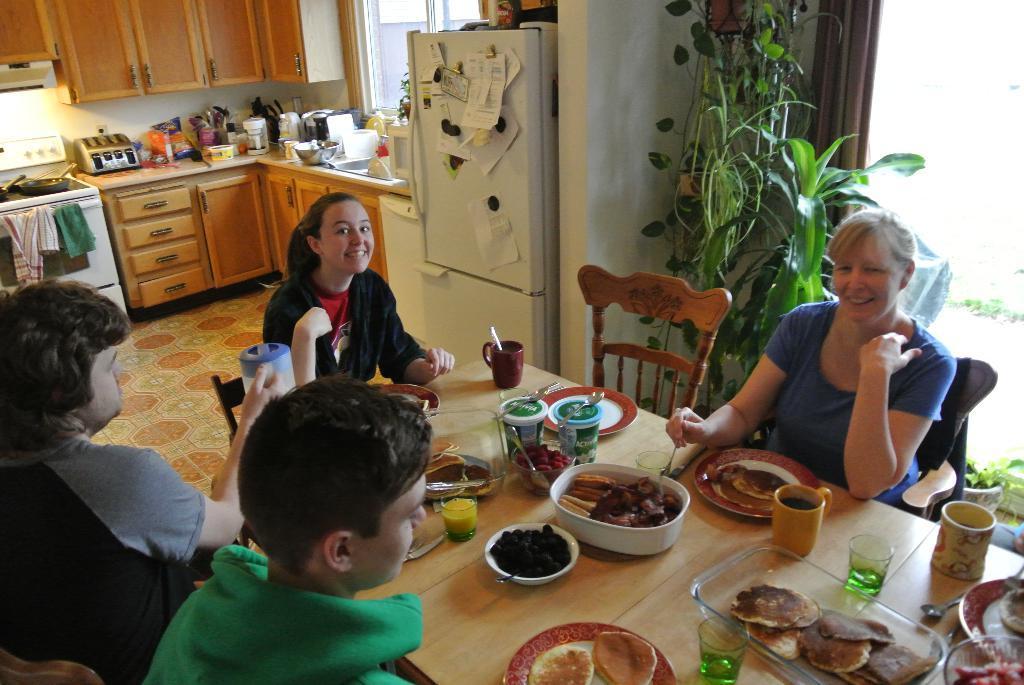How would you summarize this image in a sentence or two? In this image i can see few people sitting on chairs around the dining table, on the dining table i can see many food items in the bowls and few cups. In the background i can see the kitchen table, stove, refrigerator and plants. 